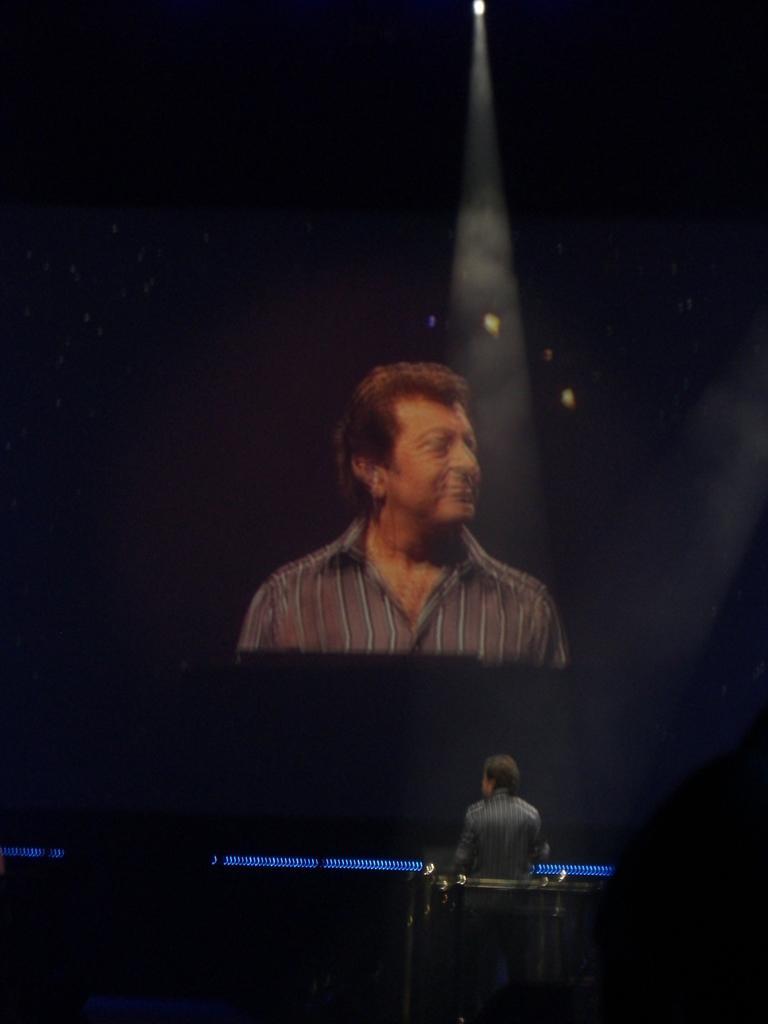Could you give a brief overview of what you see in this image? In this picture we can see a person in the front, in the background there is a screen, we can see another person on the screen, there is a light at the top of the picture. 